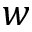<formula> <loc_0><loc_0><loc_500><loc_500>w</formula> 